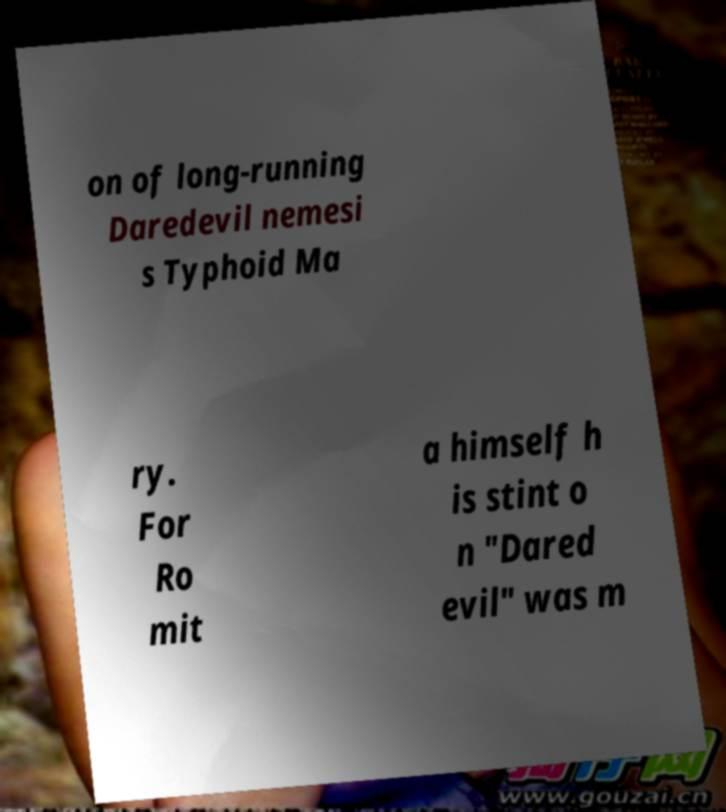Can you read and provide the text displayed in the image?This photo seems to have some interesting text. Can you extract and type it out for me? on of long-running Daredevil nemesi s Typhoid Ma ry. For Ro mit a himself h is stint o n "Dared evil" was m 